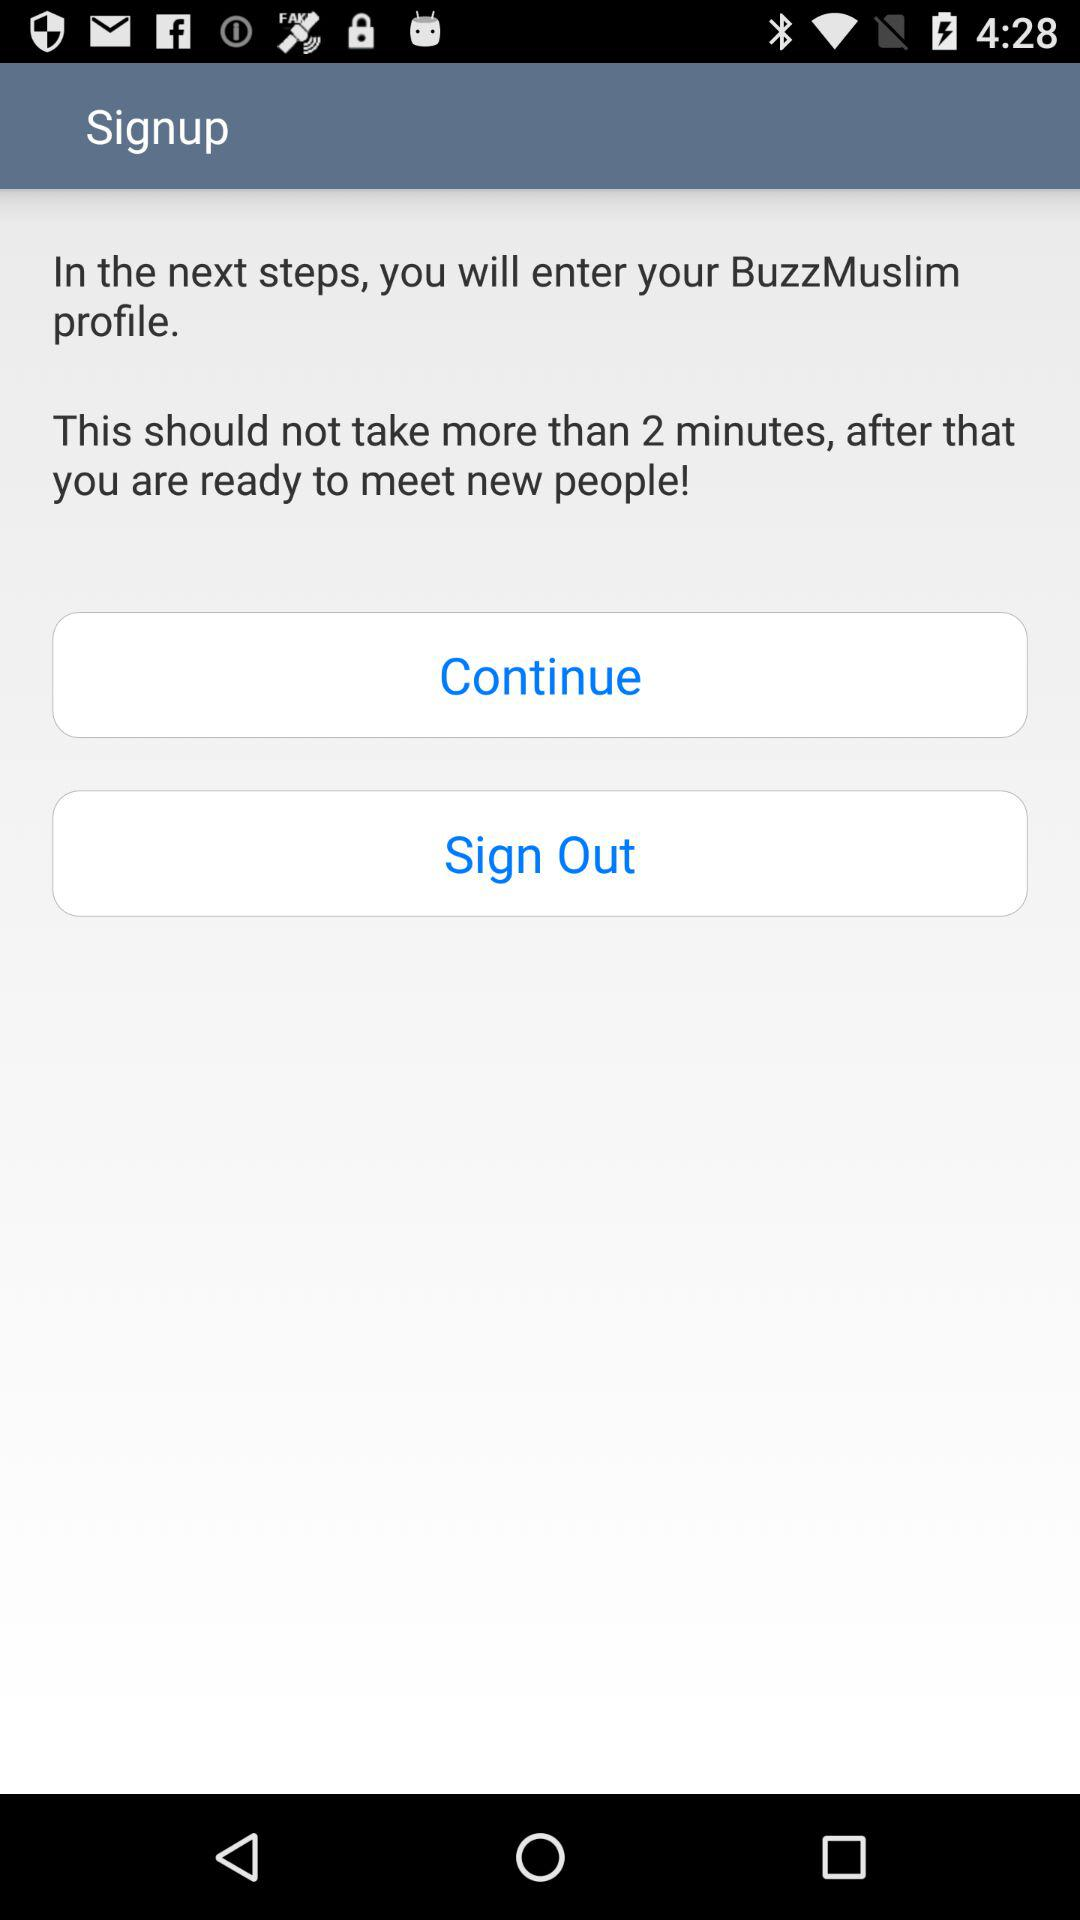What is the profile name?
When the provided information is insufficient, respond with <no answer>. <no answer> 